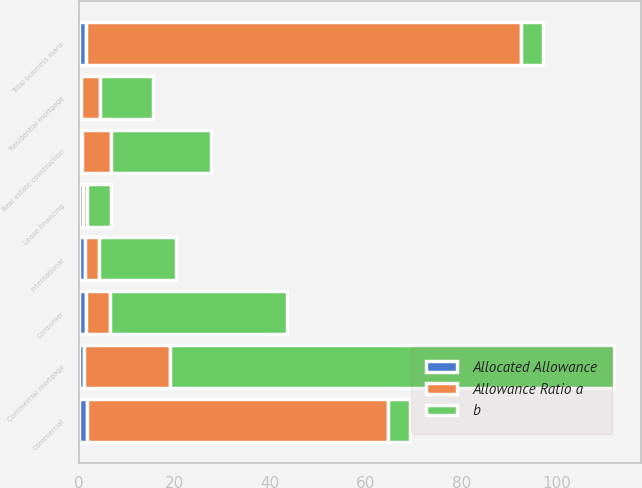<chart> <loc_0><loc_0><loc_500><loc_500><stacked_bar_chart><ecel><fcel>Commercial<fcel>Real estate construction<fcel>Commercial mortgage<fcel>Lease financing<fcel>International<fcel>Total business loans<fcel>Residential mortgage<fcel>Consumer<nl><fcel>b<fcel>4.5<fcel>21<fcel>93<fcel>5<fcel>16<fcel>4.5<fcel>11<fcel>37<nl><fcel>Allocated Allowance<fcel>1.77<fcel>0.72<fcel>1.05<fcel>0.81<fcel>1.3<fcel>1.53<fcel>0.54<fcel>1.49<nl><fcel>Allowance Ratio a<fcel>63<fcel>6<fcel>18<fcel>1<fcel>3<fcel>91<fcel>4<fcel>5<nl></chart> 